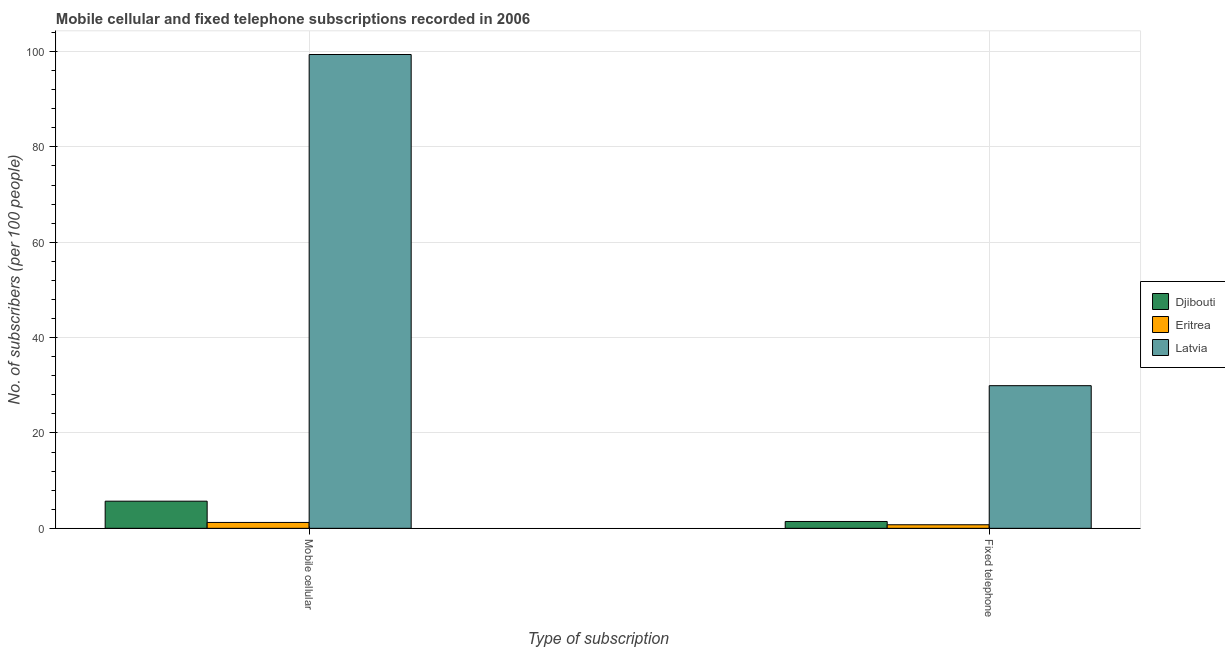How many different coloured bars are there?
Offer a very short reply. 3. How many groups of bars are there?
Offer a terse response. 2. Are the number of bars per tick equal to the number of legend labels?
Ensure brevity in your answer.  Yes. Are the number of bars on each tick of the X-axis equal?
Offer a terse response. Yes. How many bars are there on the 2nd tick from the left?
Make the answer very short. 3. How many bars are there on the 1st tick from the right?
Your answer should be compact. 3. What is the label of the 2nd group of bars from the left?
Offer a terse response. Fixed telephone. What is the number of mobile cellular subscribers in Eritrea?
Keep it short and to the point. 1.23. Across all countries, what is the maximum number of mobile cellular subscribers?
Your answer should be very brief. 99.38. Across all countries, what is the minimum number of mobile cellular subscribers?
Your response must be concise. 1.23. In which country was the number of mobile cellular subscribers maximum?
Your answer should be compact. Latvia. In which country was the number of mobile cellular subscribers minimum?
Keep it short and to the point. Eritrea. What is the total number of fixed telephone subscribers in the graph?
Provide a short and direct response. 32.1. What is the difference between the number of fixed telephone subscribers in Eritrea and that in Djibouti?
Provide a short and direct response. -0.69. What is the difference between the number of fixed telephone subscribers in Djibouti and the number of mobile cellular subscribers in Latvia?
Keep it short and to the point. -97.94. What is the average number of fixed telephone subscribers per country?
Provide a succinct answer. 10.7. What is the difference between the number of fixed telephone subscribers and number of mobile cellular subscribers in Djibouti?
Offer a very short reply. -4.26. In how many countries, is the number of mobile cellular subscribers greater than 80 ?
Ensure brevity in your answer.  1. What is the ratio of the number of mobile cellular subscribers in Djibouti to that in Eritrea?
Provide a succinct answer. 4.62. In how many countries, is the number of mobile cellular subscribers greater than the average number of mobile cellular subscribers taken over all countries?
Your response must be concise. 1. What does the 2nd bar from the left in Fixed telephone represents?
Ensure brevity in your answer.  Eritrea. What does the 3rd bar from the right in Fixed telephone represents?
Make the answer very short. Djibouti. How many bars are there?
Offer a very short reply. 6. Are all the bars in the graph horizontal?
Provide a succinct answer. No. Are the values on the major ticks of Y-axis written in scientific E-notation?
Offer a terse response. No. Does the graph contain any zero values?
Offer a terse response. No. Does the graph contain grids?
Your answer should be compact. Yes. How many legend labels are there?
Provide a short and direct response. 3. How are the legend labels stacked?
Give a very brief answer. Vertical. What is the title of the graph?
Your answer should be very brief. Mobile cellular and fixed telephone subscriptions recorded in 2006. What is the label or title of the X-axis?
Your response must be concise. Type of subscription. What is the label or title of the Y-axis?
Make the answer very short. No. of subscribers (per 100 people). What is the No. of subscribers (per 100 people) of Djibouti in Mobile cellular?
Offer a terse response. 5.69. What is the No. of subscribers (per 100 people) of Eritrea in Mobile cellular?
Ensure brevity in your answer.  1.23. What is the No. of subscribers (per 100 people) of Latvia in Mobile cellular?
Your response must be concise. 99.38. What is the No. of subscribers (per 100 people) in Djibouti in Fixed telephone?
Offer a very short reply. 1.43. What is the No. of subscribers (per 100 people) of Eritrea in Fixed telephone?
Ensure brevity in your answer.  0.75. What is the No. of subscribers (per 100 people) in Latvia in Fixed telephone?
Your answer should be compact. 29.92. Across all Type of subscription, what is the maximum No. of subscribers (per 100 people) in Djibouti?
Your response must be concise. 5.69. Across all Type of subscription, what is the maximum No. of subscribers (per 100 people) of Eritrea?
Keep it short and to the point. 1.23. Across all Type of subscription, what is the maximum No. of subscribers (per 100 people) in Latvia?
Keep it short and to the point. 99.38. Across all Type of subscription, what is the minimum No. of subscribers (per 100 people) of Djibouti?
Keep it short and to the point. 1.43. Across all Type of subscription, what is the minimum No. of subscribers (per 100 people) in Eritrea?
Ensure brevity in your answer.  0.75. Across all Type of subscription, what is the minimum No. of subscribers (per 100 people) of Latvia?
Offer a terse response. 29.92. What is the total No. of subscribers (per 100 people) in Djibouti in the graph?
Your answer should be compact. 7.13. What is the total No. of subscribers (per 100 people) of Eritrea in the graph?
Provide a succinct answer. 1.98. What is the total No. of subscribers (per 100 people) of Latvia in the graph?
Make the answer very short. 129.29. What is the difference between the No. of subscribers (per 100 people) of Djibouti in Mobile cellular and that in Fixed telephone?
Provide a succinct answer. 4.26. What is the difference between the No. of subscribers (per 100 people) of Eritrea in Mobile cellular and that in Fixed telephone?
Ensure brevity in your answer.  0.49. What is the difference between the No. of subscribers (per 100 people) of Latvia in Mobile cellular and that in Fixed telephone?
Give a very brief answer. 69.46. What is the difference between the No. of subscribers (per 100 people) in Djibouti in Mobile cellular and the No. of subscribers (per 100 people) in Eritrea in Fixed telephone?
Your response must be concise. 4.95. What is the difference between the No. of subscribers (per 100 people) in Djibouti in Mobile cellular and the No. of subscribers (per 100 people) in Latvia in Fixed telephone?
Provide a short and direct response. -24.23. What is the difference between the No. of subscribers (per 100 people) in Eritrea in Mobile cellular and the No. of subscribers (per 100 people) in Latvia in Fixed telephone?
Your response must be concise. -28.69. What is the average No. of subscribers (per 100 people) in Djibouti per Type of subscription?
Your answer should be compact. 3.56. What is the average No. of subscribers (per 100 people) of Eritrea per Type of subscription?
Provide a succinct answer. 0.99. What is the average No. of subscribers (per 100 people) in Latvia per Type of subscription?
Keep it short and to the point. 64.65. What is the difference between the No. of subscribers (per 100 people) in Djibouti and No. of subscribers (per 100 people) in Eritrea in Mobile cellular?
Provide a succinct answer. 4.46. What is the difference between the No. of subscribers (per 100 people) of Djibouti and No. of subscribers (per 100 people) of Latvia in Mobile cellular?
Provide a succinct answer. -93.69. What is the difference between the No. of subscribers (per 100 people) of Eritrea and No. of subscribers (per 100 people) of Latvia in Mobile cellular?
Your answer should be very brief. -98.15. What is the difference between the No. of subscribers (per 100 people) of Djibouti and No. of subscribers (per 100 people) of Eritrea in Fixed telephone?
Ensure brevity in your answer.  0.69. What is the difference between the No. of subscribers (per 100 people) in Djibouti and No. of subscribers (per 100 people) in Latvia in Fixed telephone?
Your answer should be compact. -28.48. What is the difference between the No. of subscribers (per 100 people) of Eritrea and No. of subscribers (per 100 people) of Latvia in Fixed telephone?
Your answer should be very brief. -29.17. What is the ratio of the No. of subscribers (per 100 people) of Djibouti in Mobile cellular to that in Fixed telephone?
Offer a terse response. 3.97. What is the ratio of the No. of subscribers (per 100 people) in Eritrea in Mobile cellular to that in Fixed telephone?
Offer a very short reply. 1.65. What is the ratio of the No. of subscribers (per 100 people) of Latvia in Mobile cellular to that in Fixed telephone?
Keep it short and to the point. 3.32. What is the difference between the highest and the second highest No. of subscribers (per 100 people) of Djibouti?
Provide a succinct answer. 4.26. What is the difference between the highest and the second highest No. of subscribers (per 100 people) in Eritrea?
Provide a succinct answer. 0.49. What is the difference between the highest and the second highest No. of subscribers (per 100 people) of Latvia?
Your answer should be very brief. 69.46. What is the difference between the highest and the lowest No. of subscribers (per 100 people) in Djibouti?
Keep it short and to the point. 4.26. What is the difference between the highest and the lowest No. of subscribers (per 100 people) in Eritrea?
Offer a very short reply. 0.49. What is the difference between the highest and the lowest No. of subscribers (per 100 people) of Latvia?
Make the answer very short. 69.46. 